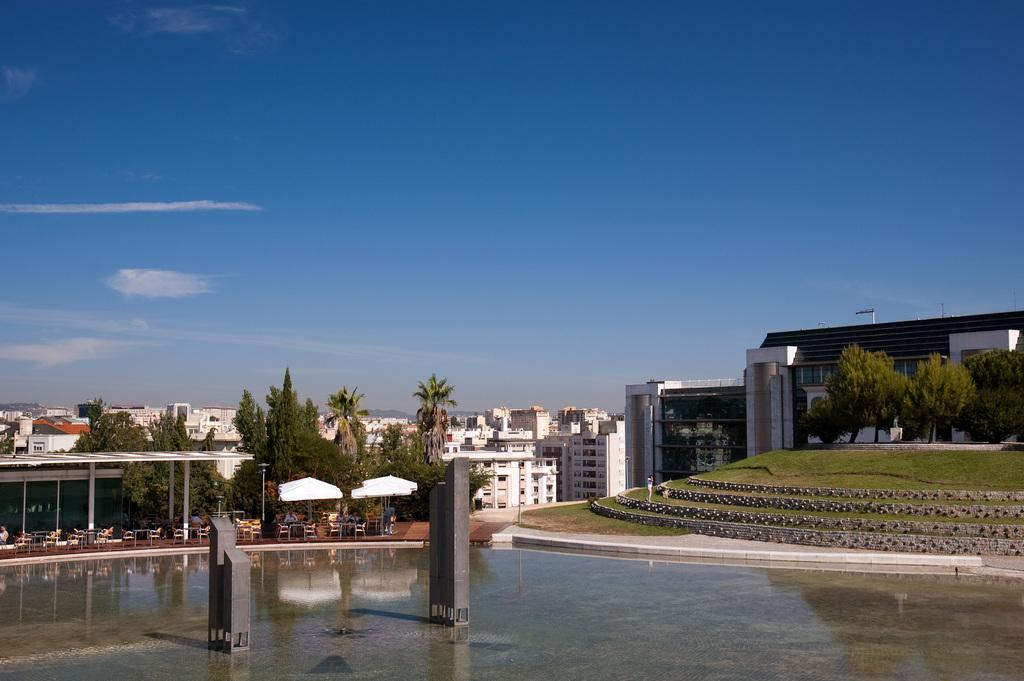What type of structures can be seen in the image? There are buildings in the image. What type of vegetation is present in the image? There are trees in the image. What type of furniture is visible in the image? There are tables and chairs in the image. What type of temporary shelter is present in the image? There are tents in the image. What type of symbol is present in the image? There is a flag in the image. What type of support structures are present in the image? There are poles in the image. Who or what is present in the image? There are people in the image. What part of the natural environment is visible in the image? The sky is visible at the top of the image, and water is visible at the bottom of the image. How many teeth can be seen on the flag in the image? There are no teeth present on the flag in the image. What type of hand is holding the tent in the image? There is no hand holding the tent in the image; the tent is standing on its own. 